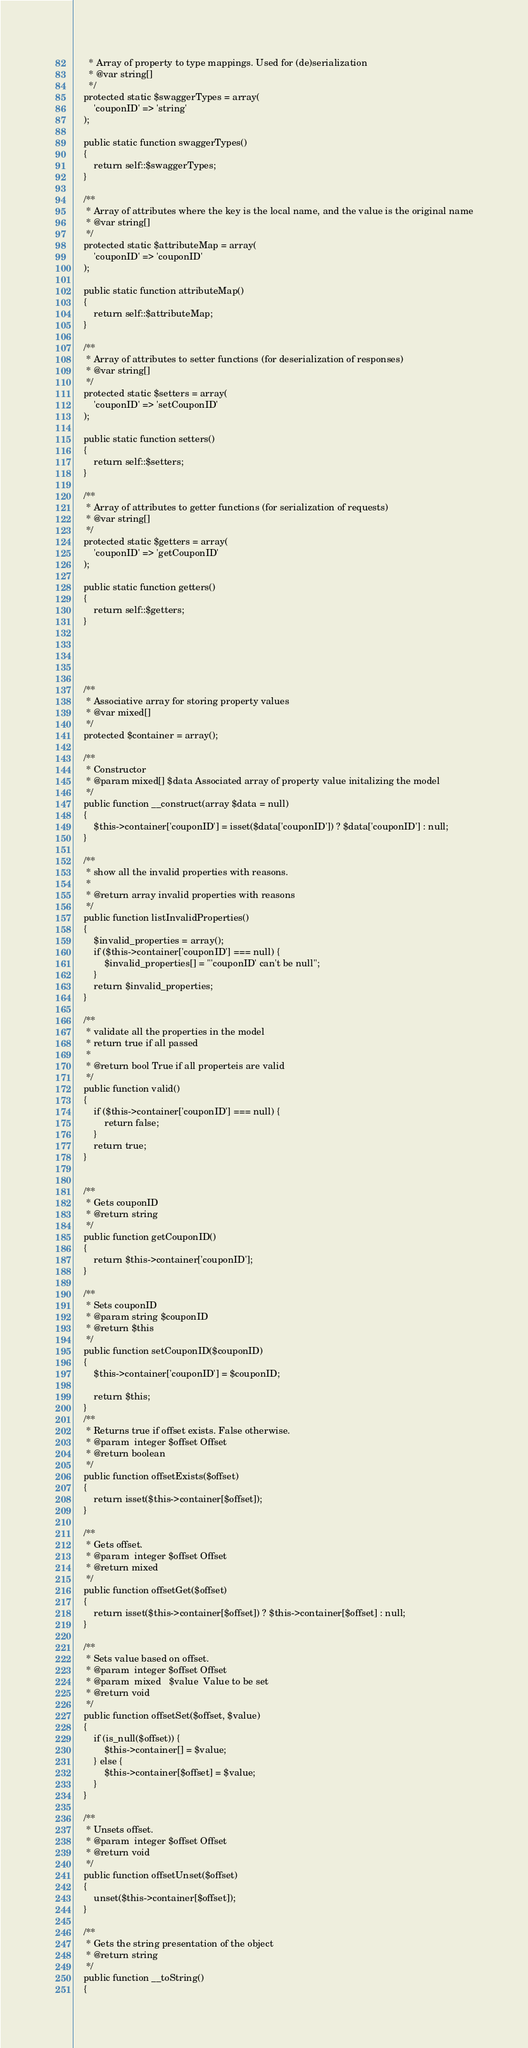<code> <loc_0><loc_0><loc_500><loc_500><_PHP_>      * Array of property to type mappings. Used for (de)serialization
      * @var string[]
      */
    protected static $swaggerTypes = array(
        'couponID' => 'string'
    );

    public static function swaggerTypes()
    {
        return self::$swaggerTypes;
    }

    /**
     * Array of attributes where the key is the local name, and the value is the original name
     * @var string[]
     */
    protected static $attributeMap = array(
        'couponID' => 'couponID'
    );

    public static function attributeMap()
    {
        return self::$attributeMap;
    }

    /**
     * Array of attributes to setter functions (for deserialization of responses)
     * @var string[]
     */
    protected static $setters = array(
        'couponID' => 'setCouponID'
    );

    public static function setters()
    {
        return self::$setters;
    }

    /**
     * Array of attributes to getter functions (for serialization of requests)
     * @var string[]
     */
    protected static $getters = array(
        'couponID' => 'getCouponID'
    );

    public static function getters()
    {
        return self::$getters;
    }

    

    

    /**
     * Associative array for storing property values
     * @var mixed[]
     */
    protected $container = array();

    /**
     * Constructor
     * @param mixed[] $data Associated array of property value initalizing the model
     */
    public function __construct(array $data = null)
    {
        $this->container['couponID'] = isset($data['couponID']) ? $data['couponID'] : null;
    }

    /**
     * show all the invalid properties with reasons.
     *
     * @return array invalid properties with reasons
     */
    public function listInvalidProperties()
    {
        $invalid_properties = array();
        if ($this->container['couponID'] === null) {
            $invalid_properties[] = "'couponID' can't be null";
        }
        return $invalid_properties;
    }

    /**
     * validate all the properties in the model
     * return true if all passed
     *
     * @return bool True if all properteis are valid
     */
    public function valid()
    {
        if ($this->container['couponID'] === null) {
            return false;
        }
        return true;
    }


    /**
     * Gets couponID
     * @return string
     */
    public function getCouponID()
    {
        return $this->container['couponID'];
    }

    /**
     * Sets couponID
     * @param string $couponID
     * @return $this
     */
    public function setCouponID($couponID)
    {
        $this->container['couponID'] = $couponID;

        return $this;
    }
    /**
     * Returns true if offset exists. False otherwise.
     * @param  integer $offset Offset
     * @return boolean
     */
    public function offsetExists($offset)
    {
        return isset($this->container[$offset]);
    }

    /**
     * Gets offset.
     * @param  integer $offset Offset
     * @return mixed
     */
    public function offsetGet($offset)
    {
        return isset($this->container[$offset]) ? $this->container[$offset] : null;
    }

    /**
     * Sets value based on offset.
     * @param  integer $offset Offset
     * @param  mixed   $value  Value to be set
     * @return void
     */
    public function offsetSet($offset, $value)
    {
        if (is_null($offset)) {
            $this->container[] = $value;
        } else {
            $this->container[$offset] = $value;
        }
    }

    /**
     * Unsets offset.
     * @param  integer $offset Offset
     * @return void
     */
    public function offsetUnset($offset)
    {
        unset($this->container[$offset]);
    }

    /**
     * Gets the string presentation of the object
     * @return string
     */
    public function __toString()
    {</code> 